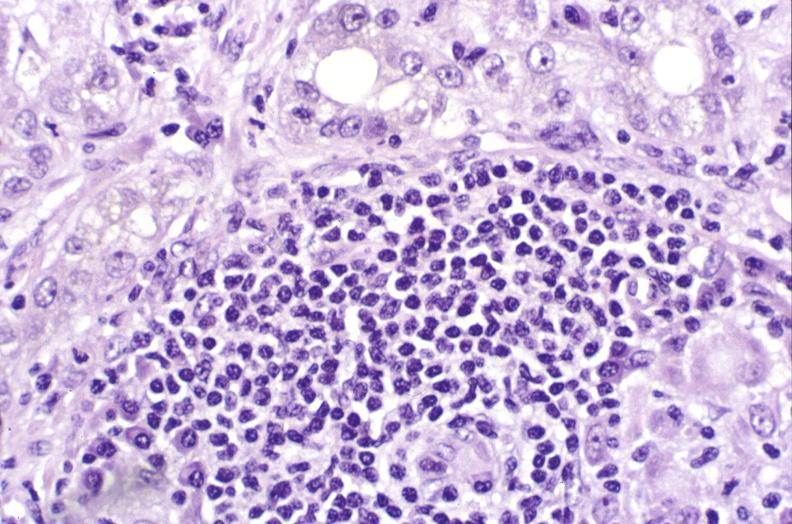s polyarteritis nodosa present?
Answer the question using a single word or phrase. No 